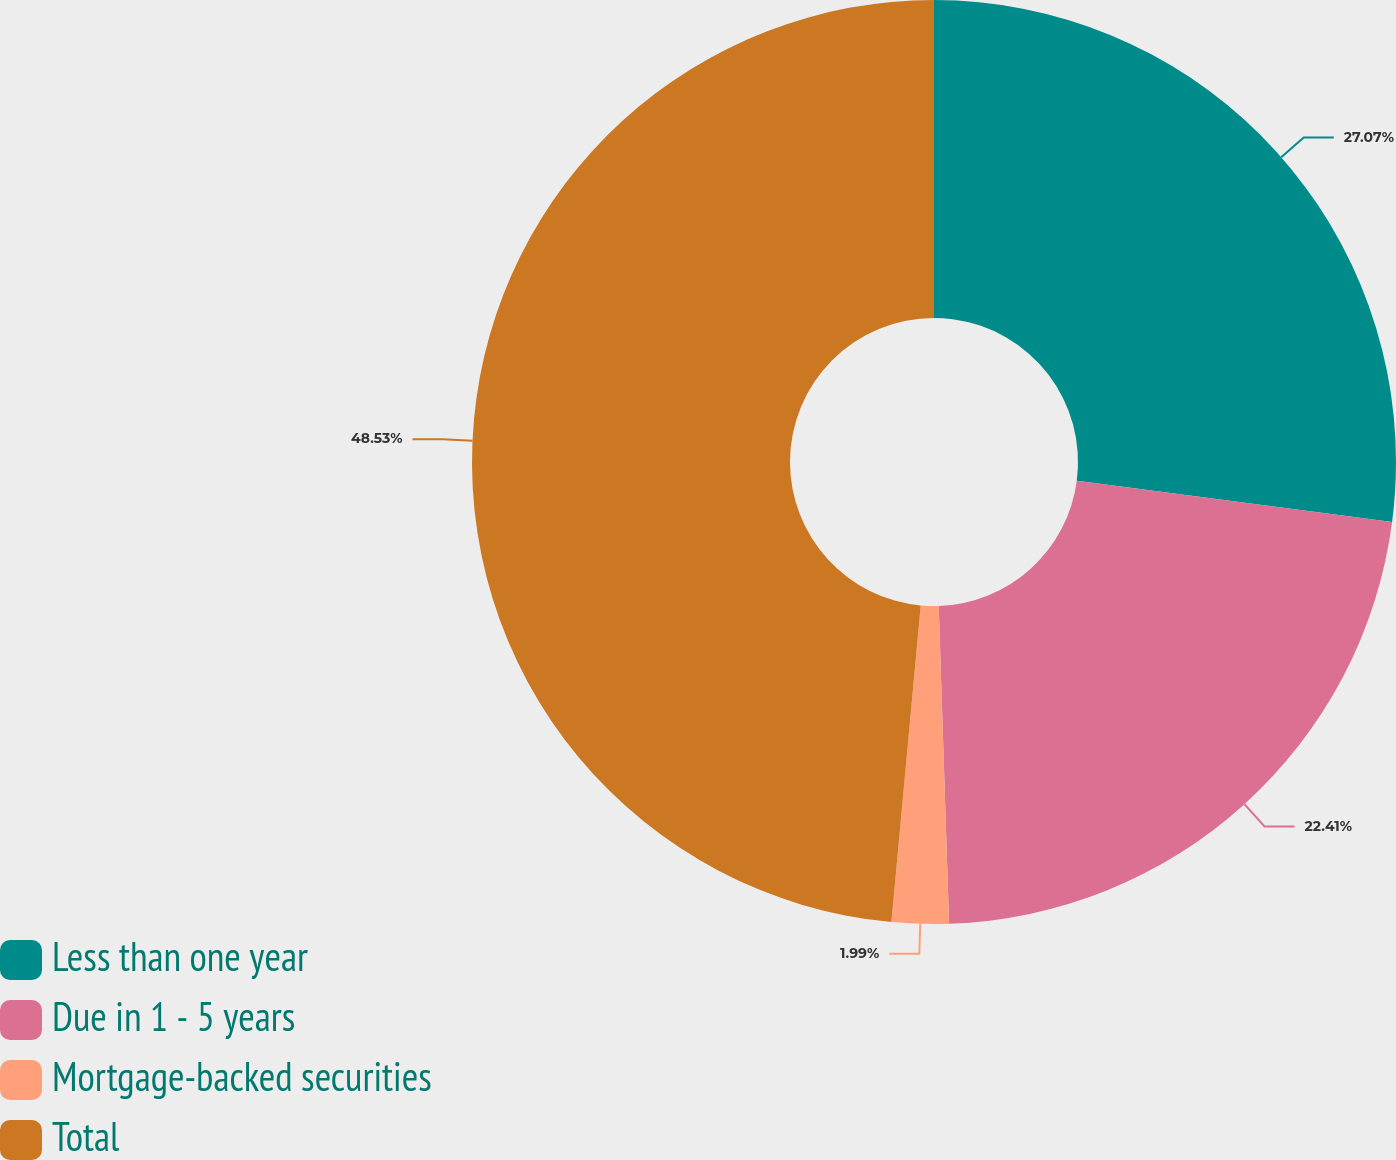Convert chart to OTSL. <chart><loc_0><loc_0><loc_500><loc_500><pie_chart><fcel>Less than one year<fcel>Due in 1 - 5 years<fcel>Mortgage-backed securities<fcel>Total<nl><fcel>27.07%<fcel>22.41%<fcel>1.99%<fcel>48.53%<nl></chart> 